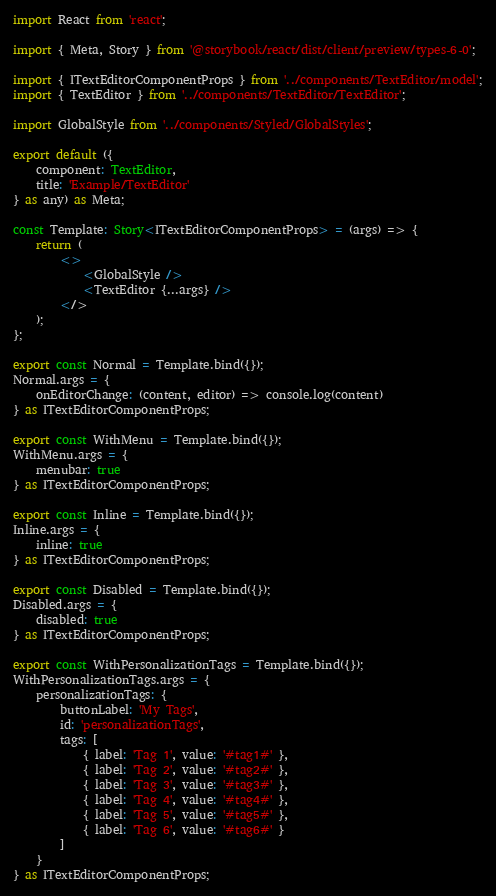<code> <loc_0><loc_0><loc_500><loc_500><_TypeScript_>import React from 'react';

import { Meta, Story } from '@storybook/react/dist/client/preview/types-6-0';

import { ITextEditorComponentProps } from '../components/TextEditor/model';
import { TextEditor } from '../components/TextEditor/TextEditor';

import GlobalStyle from '../components/Styled/GlobalStyles';

export default ({
	component: TextEditor,
	title: 'Example/TextEditor'
} as any) as Meta;

const Template: Story<ITextEditorComponentProps> = (args) => {
	return (
		<>
			<GlobalStyle />
			<TextEditor {...args} />
		</>
	);
};

export const Normal = Template.bind({});
Normal.args = {
	onEditorChange: (content, editor) => console.log(content)
} as ITextEditorComponentProps;

export const WithMenu = Template.bind({});
WithMenu.args = {
	menubar: true
} as ITextEditorComponentProps;

export const Inline = Template.bind({});
Inline.args = {
	inline: true
} as ITextEditorComponentProps;

export const Disabled = Template.bind({});
Disabled.args = {
	disabled: true
} as ITextEditorComponentProps;

export const WithPersonalizationTags = Template.bind({});
WithPersonalizationTags.args = {
	personalizationTags: {
		buttonLabel: 'My Tags',
		id: 'personalizationTags',
		tags: [
			{ label: 'Tag 1', value: '#tag1#' },
			{ label: 'Tag 2', value: '#tag2#' },
			{ label: 'Tag 3', value: '#tag3#' },
			{ label: 'Tag 4', value: '#tag4#' },
			{ label: 'Tag 5', value: '#tag5#' },
			{ label: 'Tag 6', value: '#tag6#' }
		]
	}
} as ITextEditorComponentProps;
</code> 